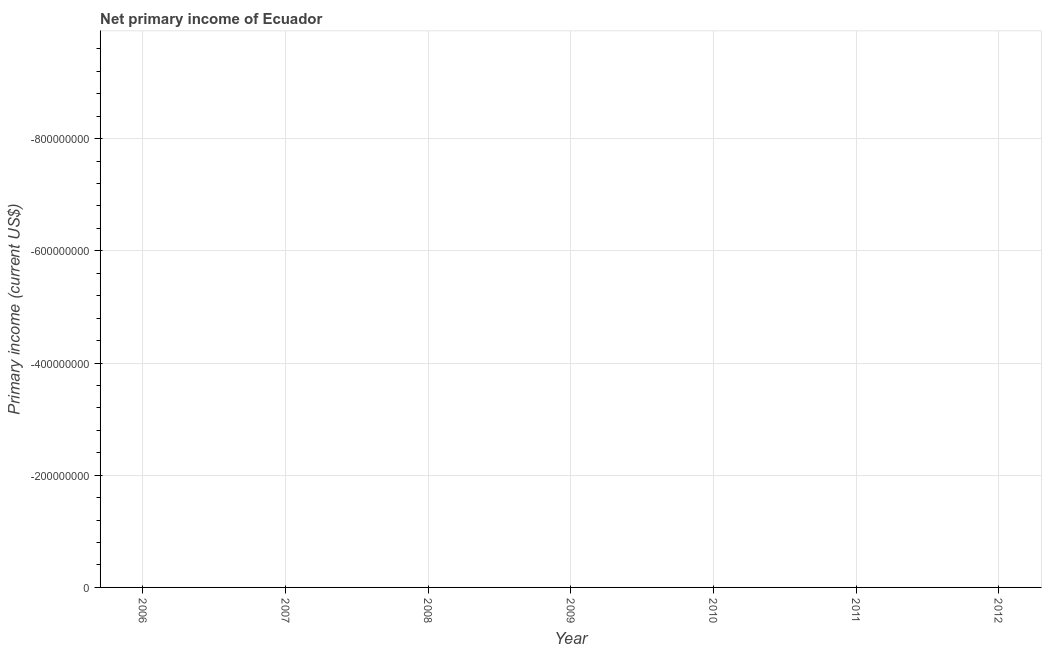What is the amount of primary income in 2011?
Keep it short and to the point. 0. What is the sum of the amount of primary income?
Your response must be concise. 0. What is the average amount of primary income per year?
Provide a succinct answer. 0. What is the median amount of primary income?
Give a very brief answer. 0. Does the amount of primary income monotonically increase over the years?
Keep it short and to the point. No. How many years are there in the graph?
Provide a short and direct response. 7. Are the values on the major ticks of Y-axis written in scientific E-notation?
Offer a terse response. No. Does the graph contain any zero values?
Ensure brevity in your answer.  Yes. What is the title of the graph?
Your answer should be very brief. Net primary income of Ecuador. What is the label or title of the X-axis?
Your response must be concise. Year. What is the label or title of the Y-axis?
Provide a short and direct response. Primary income (current US$). What is the Primary income (current US$) in 2008?
Keep it short and to the point. 0. What is the Primary income (current US$) of 2011?
Ensure brevity in your answer.  0. 